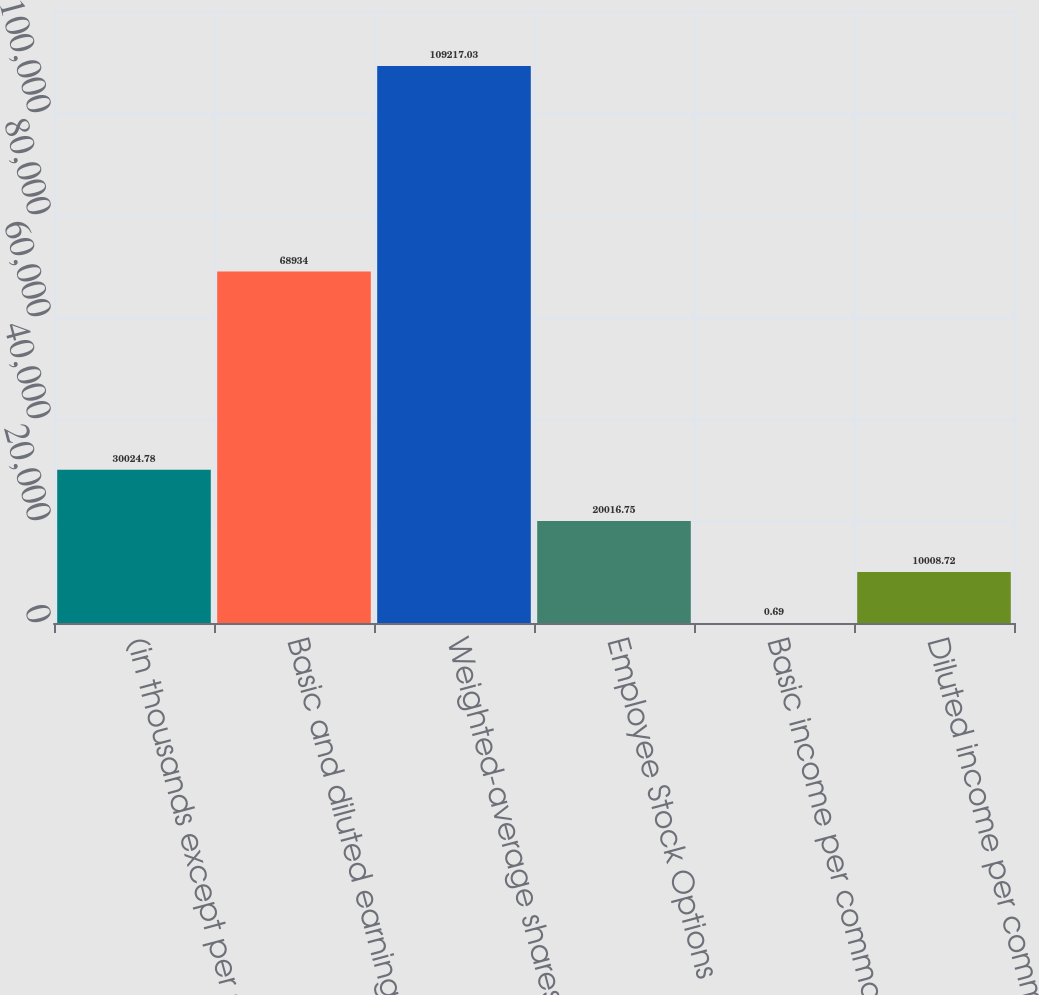<chart> <loc_0><loc_0><loc_500><loc_500><bar_chart><fcel>(in thousands except per share<fcel>Basic and diluted earnings<fcel>Weighted-average shares<fcel>Employee Stock Options<fcel>Basic income per common share<fcel>Diluted income per common<nl><fcel>30024.8<fcel>68934<fcel>109217<fcel>20016.8<fcel>0.69<fcel>10008.7<nl></chart> 